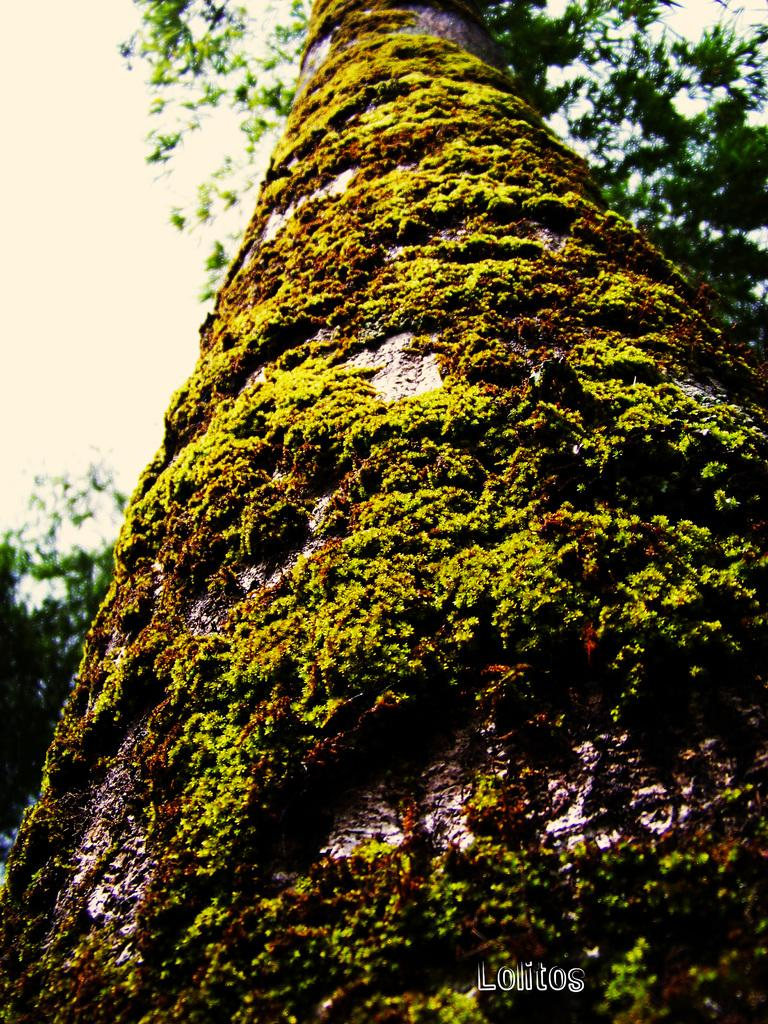What type of plant can be seen in the image? There is a tree in the image. What is covering the tree trunk? There are mosses on the tree trunk. What can be seen in the background of the image? The sky is visible in the background of the image. Is there any additional mark or feature in the image? Yes, there is a watermark in the image. What type of ring can be seen on the tree's branches in the image? There is no ring present on the tree's branches in the image. How is the distribution of mosses on the tree trunk being managed in the image? The image does not provide information about the distribution of mosses on the tree trunk or any management of it. 